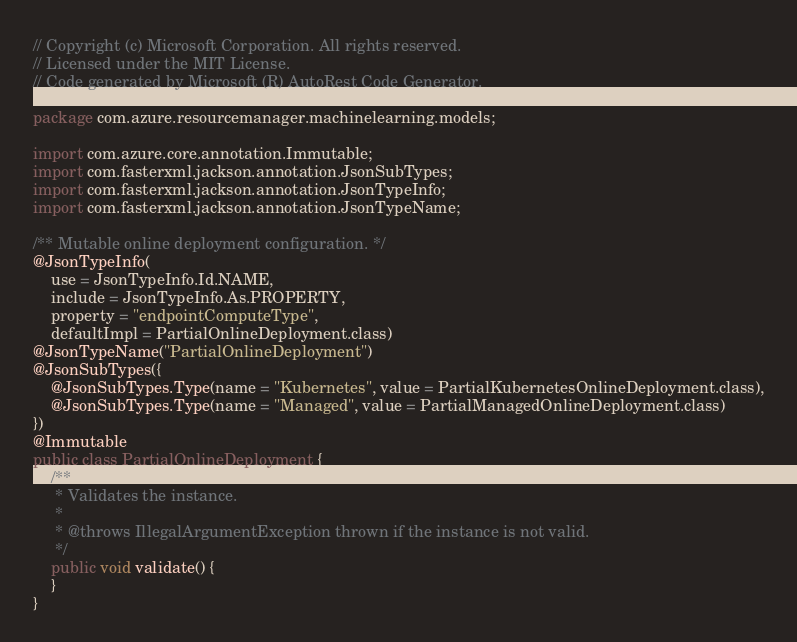<code> <loc_0><loc_0><loc_500><loc_500><_Java_>// Copyright (c) Microsoft Corporation. All rights reserved.
// Licensed under the MIT License.
// Code generated by Microsoft (R) AutoRest Code Generator.

package com.azure.resourcemanager.machinelearning.models;

import com.azure.core.annotation.Immutable;
import com.fasterxml.jackson.annotation.JsonSubTypes;
import com.fasterxml.jackson.annotation.JsonTypeInfo;
import com.fasterxml.jackson.annotation.JsonTypeName;

/** Mutable online deployment configuration. */
@JsonTypeInfo(
    use = JsonTypeInfo.Id.NAME,
    include = JsonTypeInfo.As.PROPERTY,
    property = "endpointComputeType",
    defaultImpl = PartialOnlineDeployment.class)
@JsonTypeName("PartialOnlineDeployment")
@JsonSubTypes({
    @JsonSubTypes.Type(name = "Kubernetes", value = PartialKubernetesOnlineDeployment.class),
    @JsonSubTypes.Type(name = "Managed", value = PartialManagedOnlineDeployment.class)
})
@Immutable
public class PartialOnlineDeployment {
    /**
     * Validates the instance.
     *
     * @throws IllegalArgumentException thrown if the instance is not valid.
     */
    public void validate() {
    }
}
</code> 